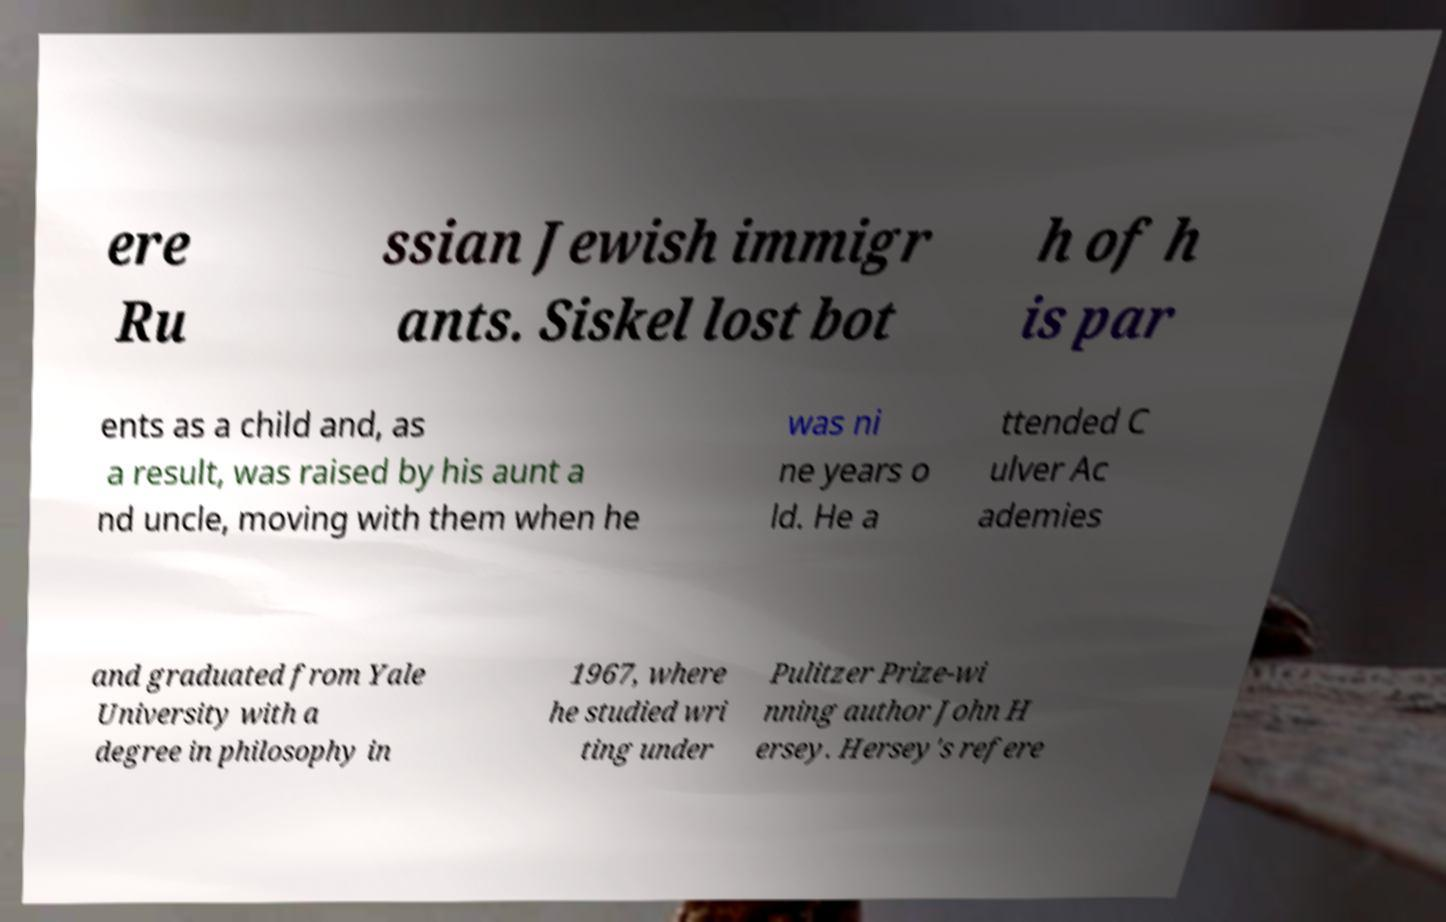Could you assist in decoding the text presented in this image and type it out clearly? ere Ru ssian Jewish immigr ants. Siskel lost bot h of h is par ents as a child and, as a result, was raised by his aunt a nd uncle, moving with them when he was ni ne years o ld. He a ttended C ulver Ac ademies and graduated from Yale University with a degree in philosophy in 1967, where he studied wri ting under Pulitzer Prize-wi nning author John H ersey. Hersey's refere 